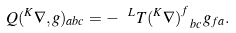<formula> <loc_0><loc_0><loc_500><loc_500>Q ( ^ { K } \nabla , g ) _ { a b c } = - \ ^ { L } T ( ^ { K } \nabla ) ^ { f } _ { \ b c } g _ { f a } .</formula> 